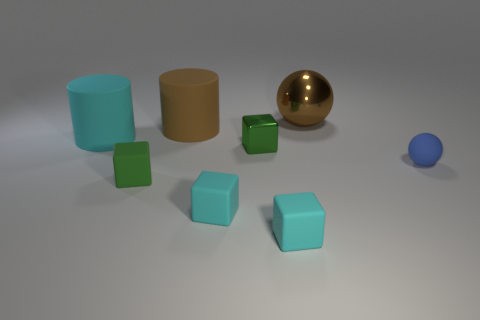What shape is the tiny blue thing?
Your response must be concise. Sphere. What number of cylinders are tiny green shiny objects or large matte objects?
Offer a very short reply. 2. Is the number of objects that are to the left of the tiny metal cube the same as the number of large cylinders in front of the shiny sphere?
Offer a terse response. No. There is a cylinder that is to the right of the small green object that is in front of the tiny blue object; what number of tiny green blocks are on the left side of it?
Keep it short and to the point. 1. What is the shape of the rubber thing that is the same color as the tiny shiny cube?
Your answer should be very brief. Cube. Is the color of the small shiny object the same as the small rubber object that is behind the small green rubber thing?
Keep it short and to the point. No. Are there more balls to the left of the cyan cylinder than tiny spheres?
Your answer should be very brief. No. How many objects are cylinders to the right of the cyan rubber cylinder or matte cylinders that are behind the large cyan thing?
Your answer should be very brief. 1. What size is the green object that is the same material as the big cyan cylinder?
Offer a very short reply. Small. There is a brown thing in front of the large brown ball; is it the same shape as the green metal object?
Your answer should be compact. No. 